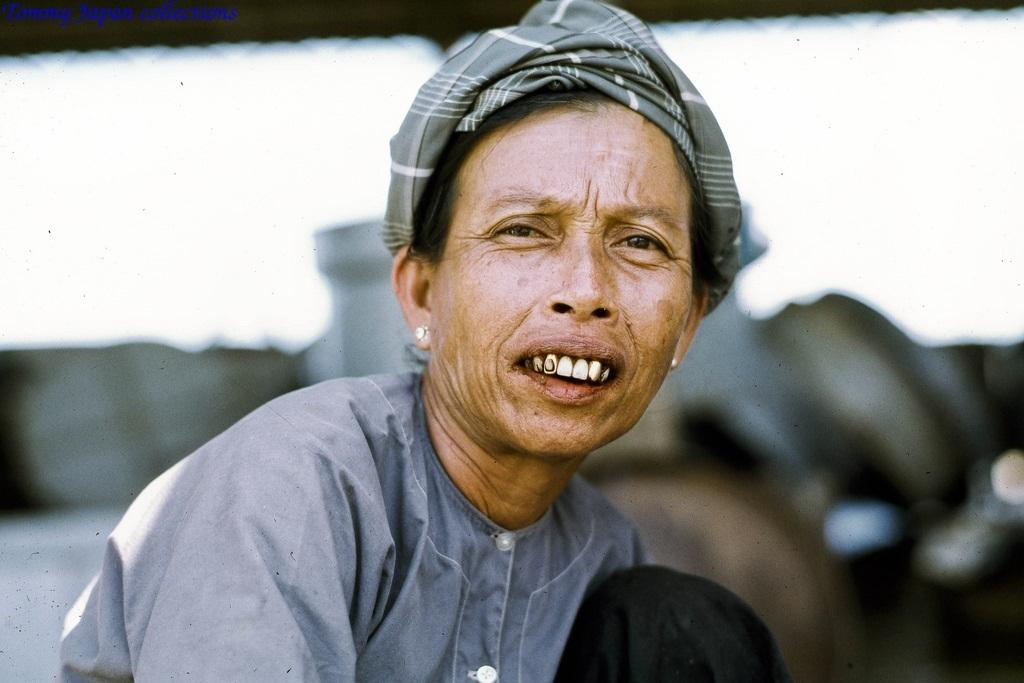Who is the main subject in the image? There is a woman in the image. What is the woman's role or occupation? The woman is a worker in an organization. Can you describe the background of the image? The background of the image is blurry. What type of animal can be seen in the image? There is no animal present in the image. How does the woman care for the crowd in the image? There is no crowd present in the image, and the woman's role is not related to caring for a crowd. 